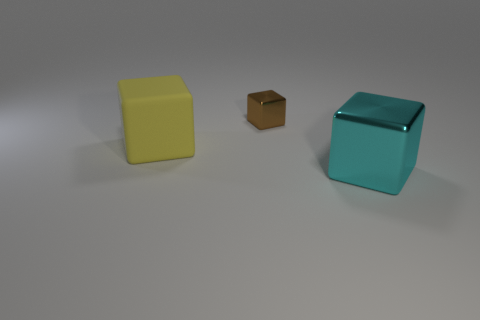Subtract all large cubes. How many cubes are left? 1 Add 2 blue cylinders. How many objects exist? 5 Subtract all gray blocks. Subtract all brown balls. How many blocks are left? 3 Subtract 0 green cylinders. How many objects are left? 3 Subtract all tiny metallic things. Subtract all big cyan cubes. How many objects are left? 1 Add 3 yellow things. How many yellow things are left? 4 Add 3 large cubes. How many large cubes exist? 5 